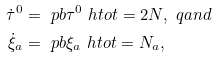<formula> <loc_0><loc_0><loc_500><loc_500>\dot { \tau } ^ { 0 } & = \ p b { \tau ^ { 0 } } { \ h t o t } = 2 N , \ q a n d \\ \dot { \xi } _ { a } & = \ p b { \xi _ { a } } { \ h t o t } = N _ { a } ,</formula> 